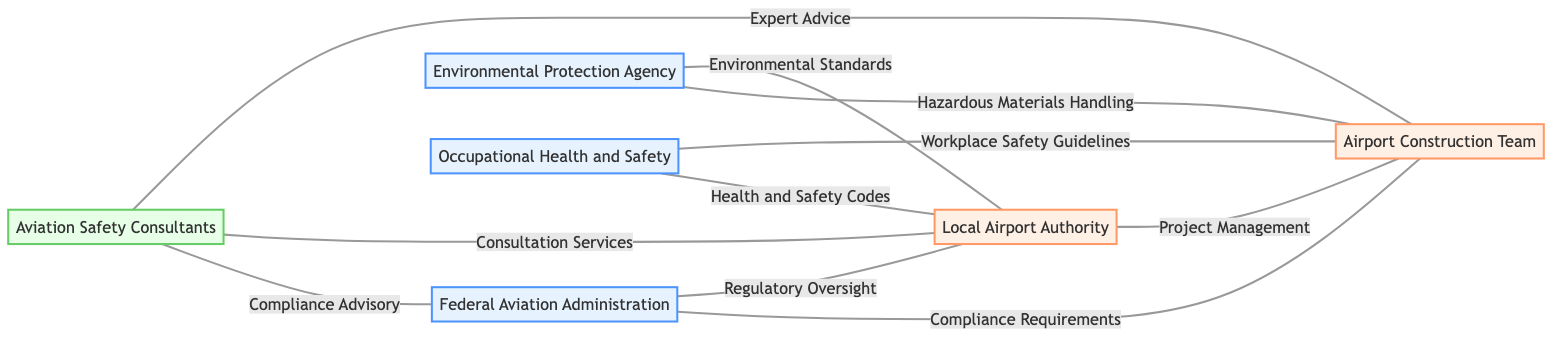What are the regulatory bodies involved in airport construction? The diagram lists three regulatory bodies: the Federal Aviation Administration (FAA), the Environmental Protection Agency (EPA), and Occupational Health and Safety (OHS).
Answer: FAA, EPA, OHS How many nodes are present in the diagram? The diagram includes six distinct nodes: FAA, EPA, OHS, Airport Authority, Construction Team, and Consultants. Counting these gives us a total of six nodes.
Answer: 6 What type of relationship exists between FAA and Construction Team? The diagram indicates a "Compliance Requirements" relationship between the Federal Aviation Administration and the Airport Construction Team, showing that the FAA sets compliance standards for the team.
Answer: Compliance Requirements Which organization provides expert advice to the Construction Team? According to the diagram, Aviation Safety Consultants offer expert advice to the Airport Construction Team, as suggested by the connection labeled "Expert Advice".
Answer: Aviation Safety Consultants How many edges are connected to the Airport Authority? The diagram shows that the Local Airport Authority has four connections: to FAA, EPA, OHS, and Construction Team. Thus, the number of edges connected to the Airport Authority is four.
Answer: 4 What is the relationship between EPA and Airport Authority? The connection between the Environmental Protection Agency and Local Airport Authority is labeled "Environmental Standards", indicating that the EPA provides environmental regulations that the Airport Authority needs to follow.
Answer: Environmental Standards Which node is connected to both the Construction Team and FAA? The diagram shows that the Federal Aviation Administration is connected to the Airport Construction Team via a "Compliance Requirements" edge. Therefore, FAA is the node connected to both the Construction Team and itself.
Answer: FAA What is the role of the Consultants concerning FAA? The diagram specifies a connection labeled "Compliance Advisory", indicating that Aviation Safety Consultants provide advisory services to the Federal Aviation Administration regarding compliance matters.
Answer: Compliance Advisory What connectors are used to illustrate relationships in the diagram? The relationships in the diagram are illustrated using edges that symbolize various types of interactions, such as regulatory oversight, compliance requirements, and expert advice.
Answer: Edges 